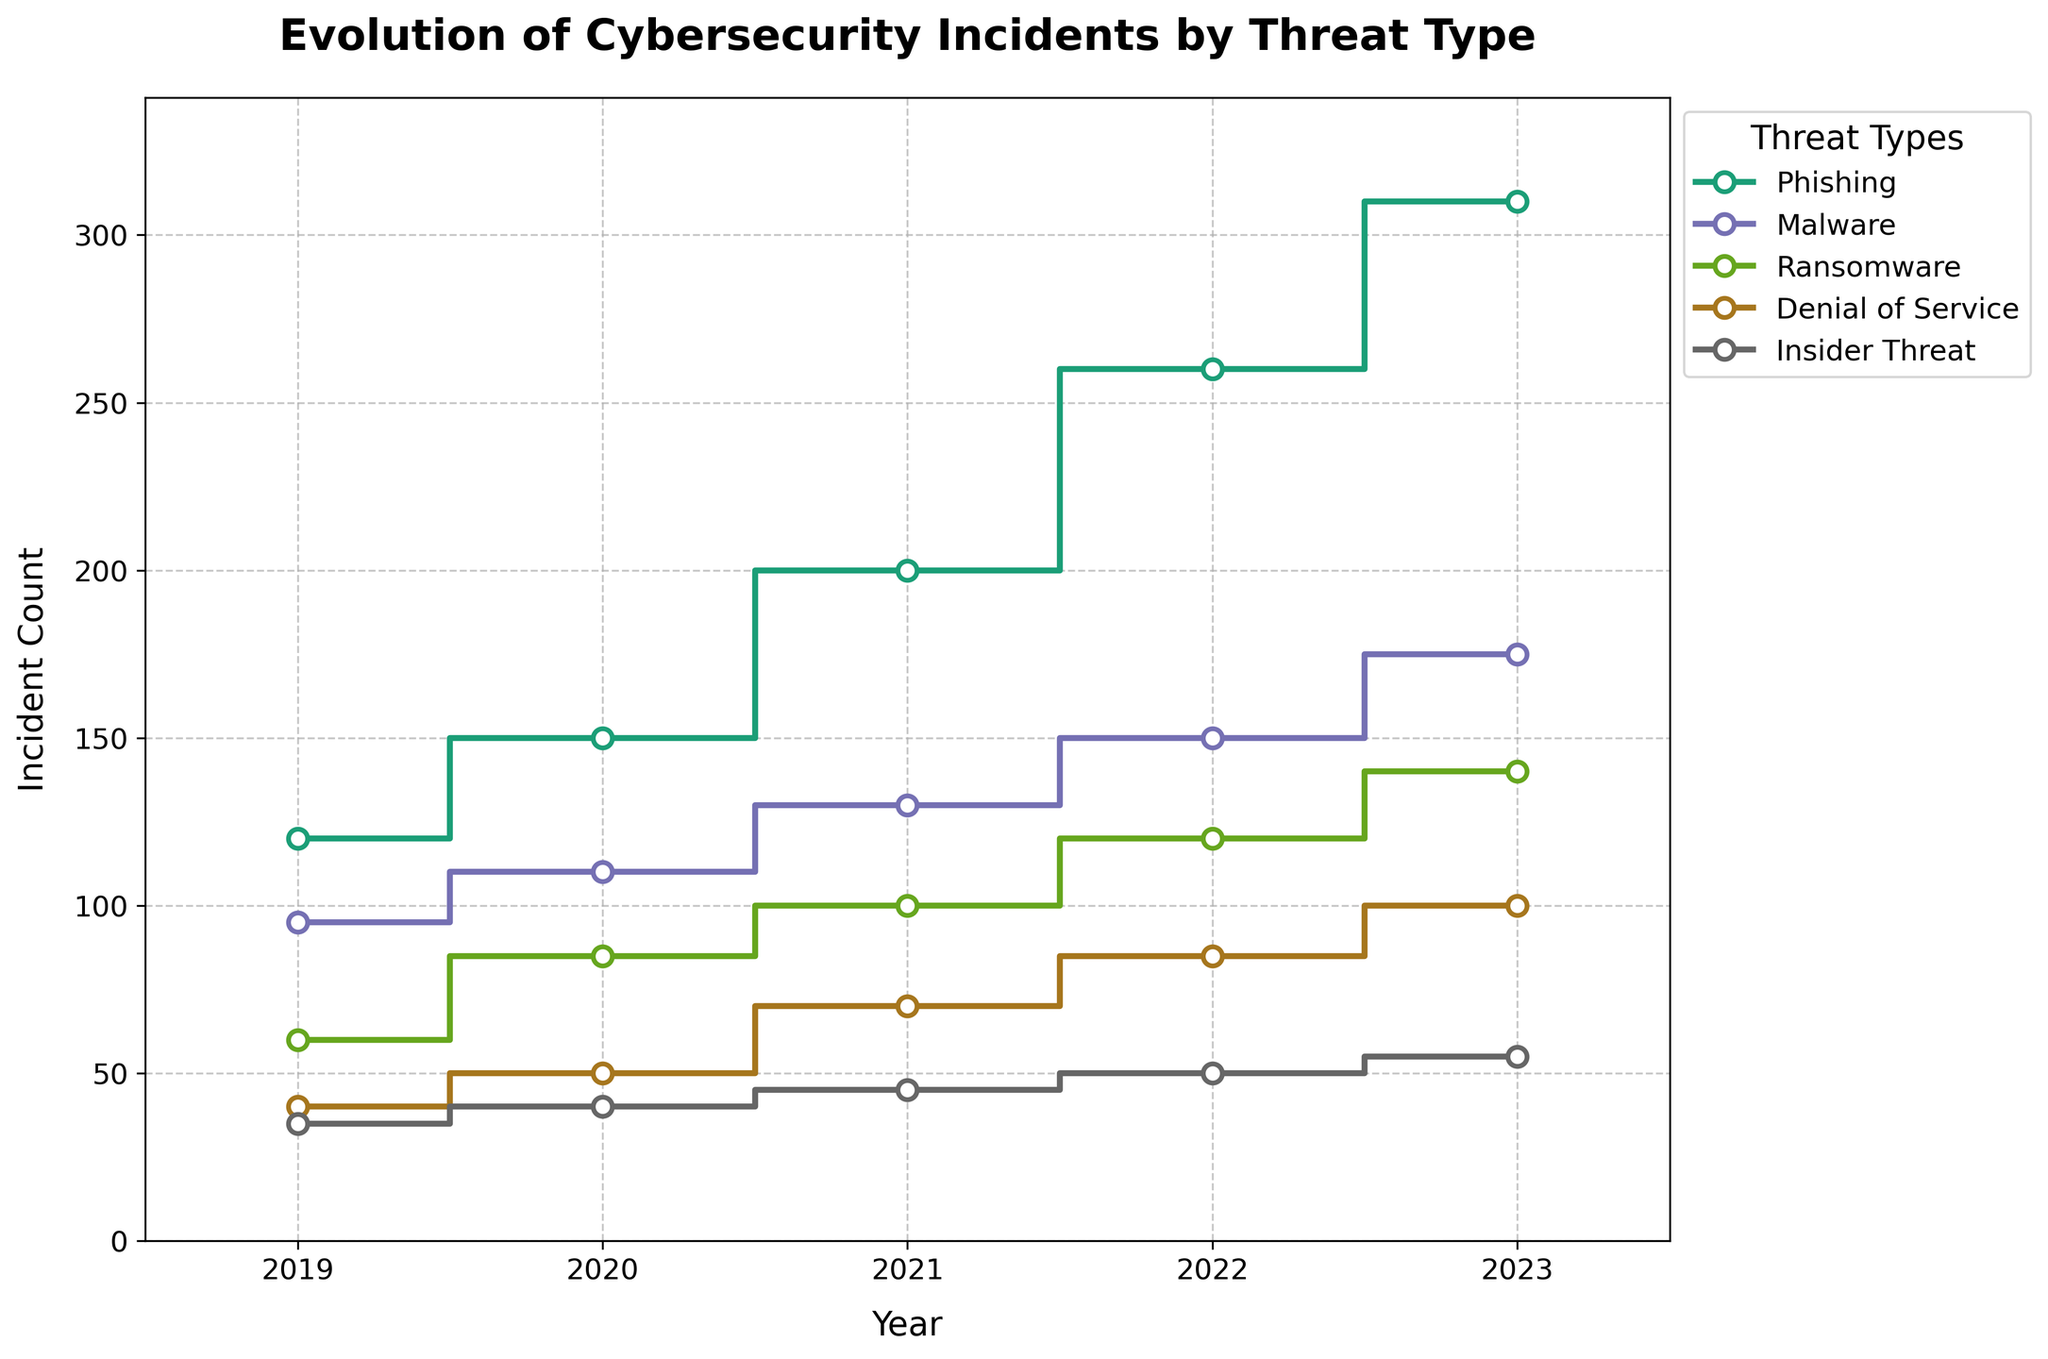What's the title of the figure? The title is typically found at the top of the figure and clearly indicates the context of the data being presented. In this case, the title reads "Evolution of Cybersecurity Incidents by Threat Type".
Answer: Evolution of Cybersecurity Incidents by Threat Type Which cybersecurity threat type had the highest number of incidents in 2023? To find the highest number of incidents for a specific year, look for the year indicated on the x-axis and then check the values represented on the y-axis for that year. In 2023, Phishing had the highest number of incidents.
Answer: Phishing How many different threat types are plotted in the figure? By looking at the legend on the plot, which lists all the different threat types, we can count the number of unique categories. The threat types in the plot are Phishing, Malware, Ransomware, Denial of Service, and Insider Threat.
Answer: 5 What is the general trend in the number of phishing incidents from 2019 to 2023? Analyze the step progression of the Phishing data points from left to right, starting in 2019 to 2023. The number of Phishing incidents consistently increases each year, indicating an upward trend.
Answer: Increasing Which year saw the most significant increase in ransomware incidents compared to the previous year? To determine this, compare the differences in ransomware incidents year by year. The incidents increased by 25 from 2019 to 2020 (60 to 85), by 15 from 2020 to 2021 (85 to 100), by 20 from 2021 to 2022 (100 to 120), and by 20 from 2022 to 2023 (120 to 140). The most significant increase, therefore, was from 2019 to 2020.
Answer: 2019 to 2020 On average, how many incidents of Malware occurred per year over the observed period? Add the yearly incidents for Malware and divide by the number of years (2019-2023). The total number of Malware incidents is 95 + 110 + 130 + 150 + 175 = 660. There are 5 years, so the average is 660/5.
Answer: 132 Was there any year where the number of Denial of Service incidents decreased compared to the previous year? Check the progression of Denial of Service incidents year by year. Each year, the count increases: 40 in 2019, 50 in 2020, 70 in 2021, 85 in 2022, and 100 in 2023. There is no year where a decrease is observed.
Answer: No Which threat type shows the least variation in incident counts over the years? To determine variation, we observe the range of values for each threat type. Insider Threats vary from 35 to 55, a range of 20. Phishing varies from 120 to 310, Malware from 95 to 175, Ransomware from 60 to 140, and Denial of Service from 40 to 100. Insider Threats show the least variation.
Answer: Insider Threat 